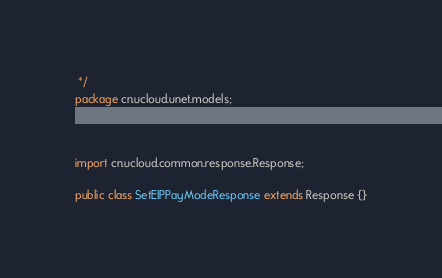<code> <loc_0><loc_0><loc_500><loc_500><_Java_> */
package cn.ucloud.unet.models;



import cn.ucloud.common.response.Response;

public class SetEIPPayModeResponse extends Response {}
</code> 